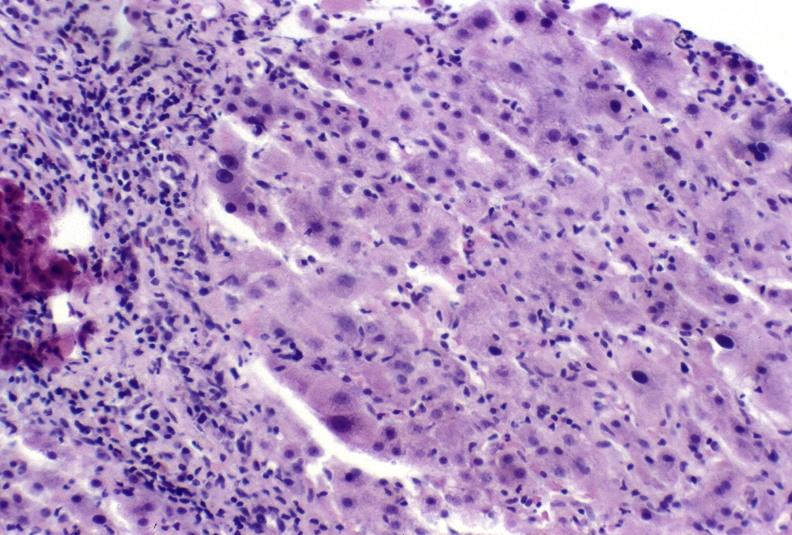does leg show autoimmune hepatitis?
Answer the question using a single word or phrase. No 